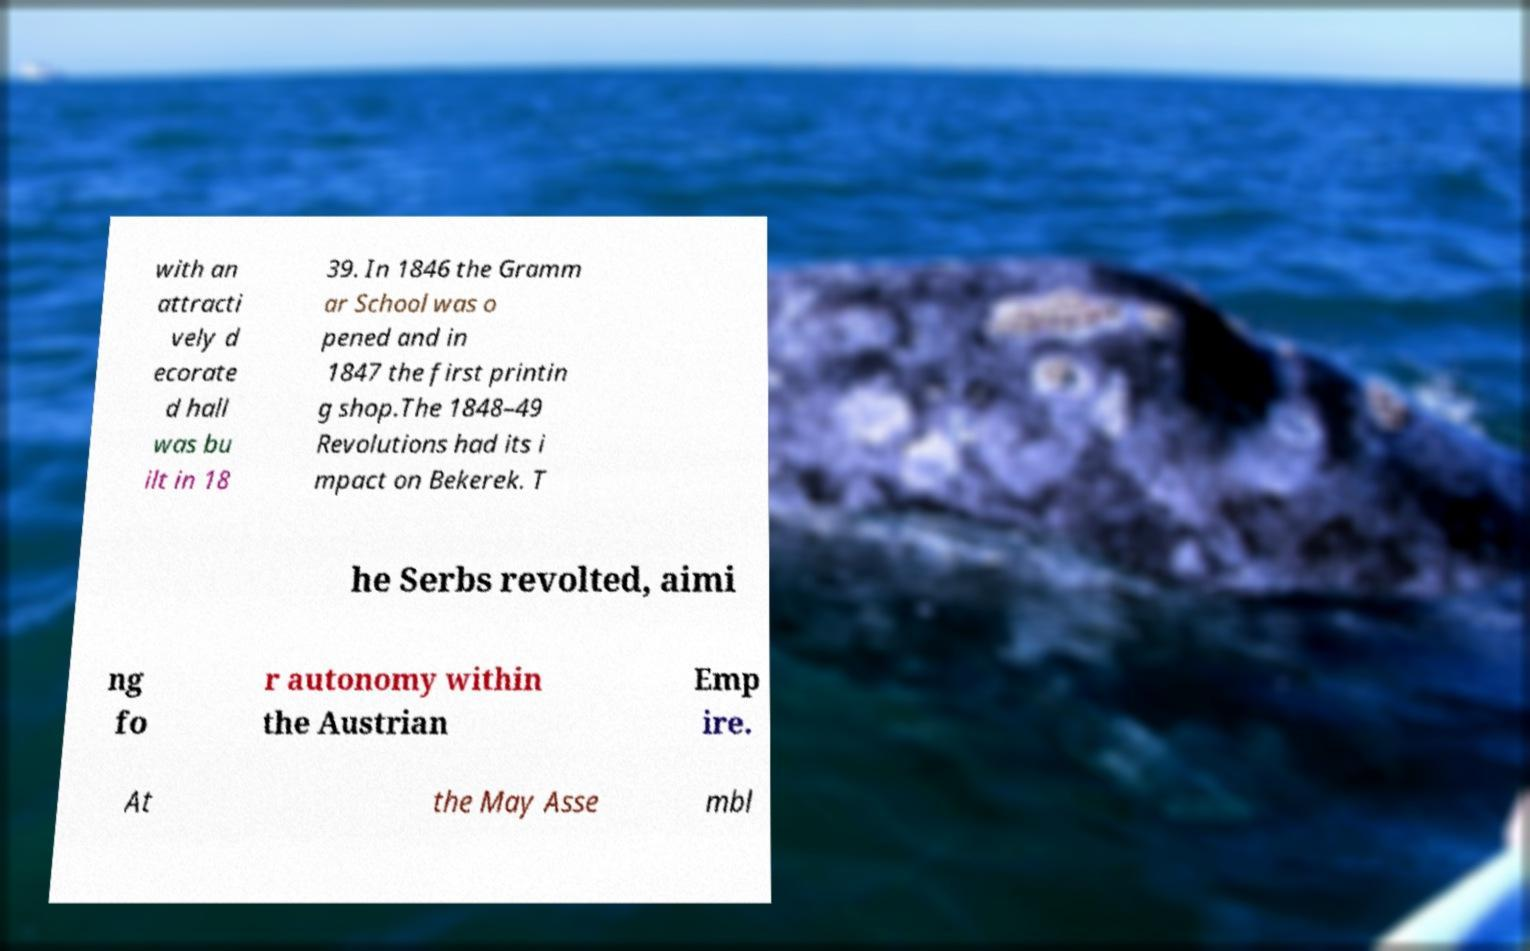Can you accurately transcribe the text from the provided image for me? with an attracti vely d ecorate d hall was bu ilt in 18 39. In 1846 the Gramm ar School was o pened and in 1847 the first printin g shop.The 1848–49 Revolutions had its i mpact on Bekerek. T he Serbs revolted, aimi ng fo r autonomy within the Austrian Emp ire. At the May Asse mbl 